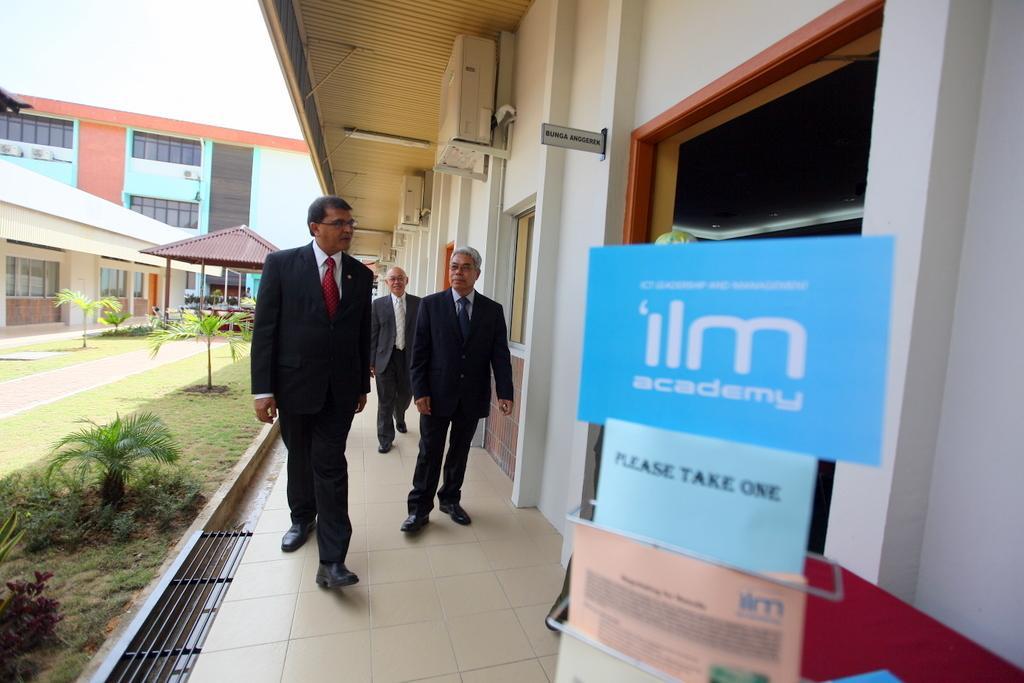Please provide a concise description of this image. In this picture there are people in the center of the image and there are pamphlets on the right side of the image and there are buildings and plants in the background area of the image, there is roof at the top side of the image. 